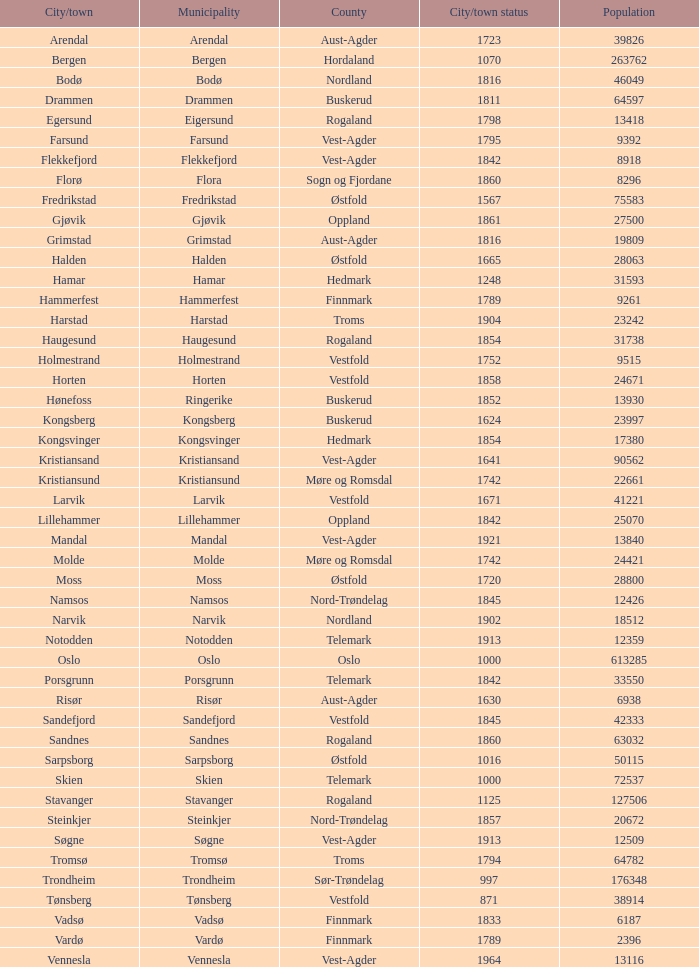Which cities or towns can be found within the horten municipality? Horten. 